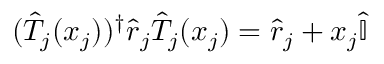<formula> <loc_0><loc_0><loc_500><loc_500>( { \hat { T } } _ { j } ( x _ { j } ) ) ^ { \dagger } { \hat { r } } _ { j } { \hat { T } } _ { j } ( x _ { j } ) = { \hat { r } } _ { j } + x _ { j } { \hat { \mathbb { I } } }</formula> 